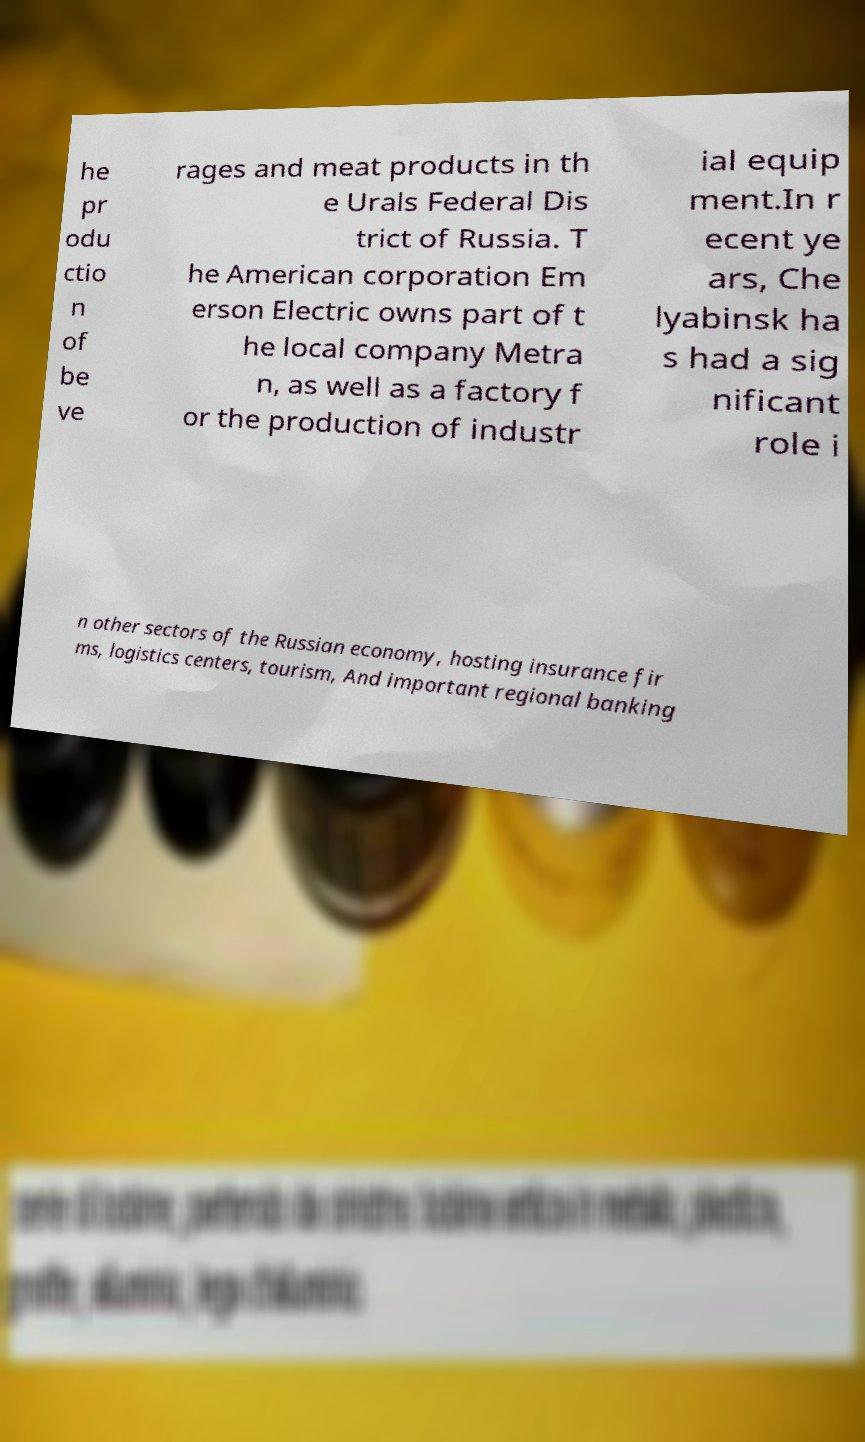For documentation purposes, I need the text within this image transcribed. Could you provide that? he pr odu ctio n of be ve rages and meat products in th e Urals Federal Dis trict of Russia. T he American corporation Em erson Electric owns part of t he local company Metra n, as well as a factory f or the production of industr ial equip ment.In r ecent ye ars, Che lyabinsk ha s had a sig nificant role i n other sectors of the Russian economy, hosting insurance fir ms, logistics centers, tourism, And important regional banking 